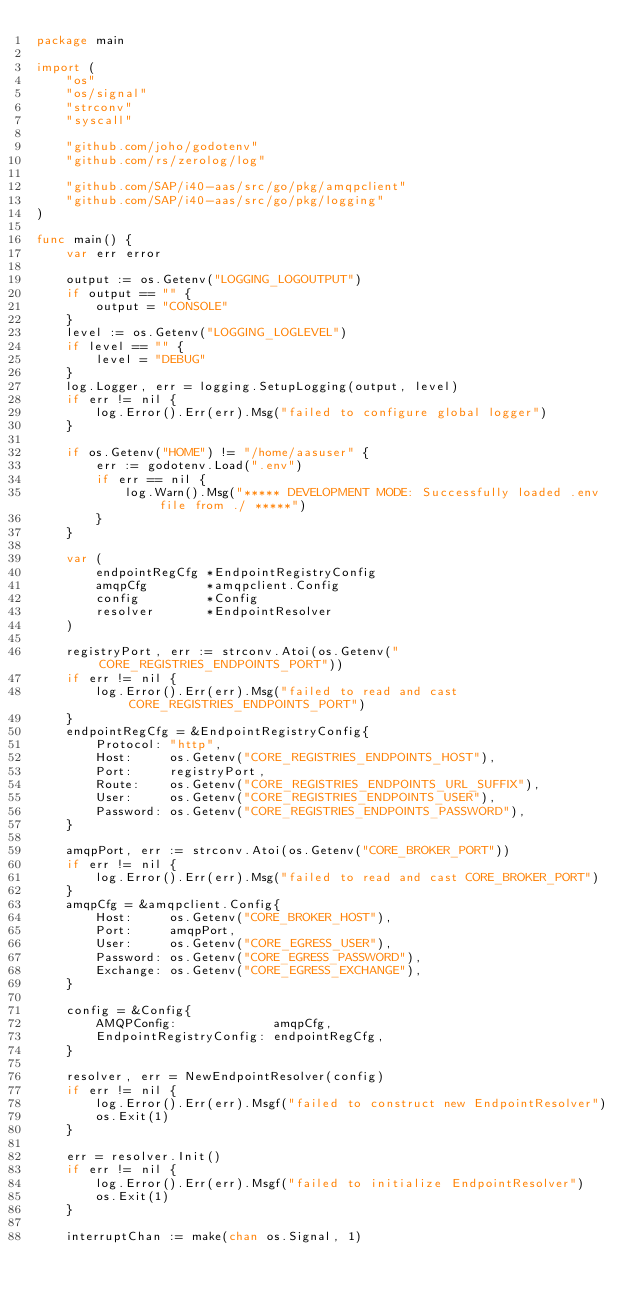Convert code to text. <code><loc_0><loc_0><loc_500><loc_500><_Go_>package main

import (
	"os"
	"os/signal"
	"strconv"
	"syscall"

	"github.com/joho/godotenv"
	"github.com/rs/zerolog/log"

	"github.com/SAP/i40-aas/src/go/pkg/amqpclient"
	"github.com/SAP/i40-aas/src/go/pkg/logging"
)

func main() {
	var err error

	output := os.Getenv("LOGGING_LOGOUTPUT")
	if output == "" {
		output = "CONSOLE"
	}
	level := os.Getenv("LOGGING_LOGLEVEL")
	if level == "" {
		level = "DEBUG"
	}
	log.Logger, err = logging.SetupLogging(output, level)
	if err != nil {
		log.Error().Err(err).Msg("failed to configure global logger")
	}

	if os.Getenv("HOME") != "/home/aasuser" {
		err := godotenv.Load(".env")
		if err == nil {
			log.Warn().Msg("***** DEVELOPMENT MODE: Successfully loaded .env file from ./ *****")
		}
	}

	var (
		endpointRegCfg *EndpointRegistryConfig
		amqpCfg        *amqpclient.Config
		config         *Config
		resolver       *EndpointResolver
	)

	registryPort, err := strconv.Atoi(os.Getenv("CORE_REGISTRIES_ENDPOINTS_PORT"))
	if err != nil {
		log.Error().Err(err).Msg("failed to read and cast CORE_REGISTRIES_ENDPOINTS_PORT")
	}
	endpointRegCfg = &EndpointRegistryConfig{
		Protocol: "http",
		Host:     os.Getenv("CORE_REGISTRIES_ENDPOINTS_HOST"),
		Port:     registryPort,
		Route:    os.Getenv("CORE_REGISTRIES_ENDPOINTS_URL_SUFFIX"),
		User:     os.Getenv("CORE_REGISTRIES_ENDPOINTS_USER"),
		Password: os.Getenv("CORE_REGISTRIES_ENDPOINTS_PASSWORD"),
	}

	amqpPort, err := strconv.Atoi(os.Getenv("CORE_BROKER_PORT"))
	if err != nil {
		log.Error().Err(err).Msg("failed to read and cast CORE_BROKER_PORT")
	}
	amqpCfg = &amqpclient.Config{
		Host:     os.Getenv("CORE_BROKER_HOST"),
		Port:     amqpPort,
		User:     os.Getenv("CORE_EGRESS_USER"),
		Password: os.Getenv("CORE_EGRESS_PASSWORD"),
		Exchange: os.Getenv("CORE_EGRESS_EXCHANGE"),
	}

	config = &Config{
		AMQPConfig:             amqpCfg,
		EndpointRegistryConfig: endpointRegCfg,
	}

	resolver, err = NewEndpointResolver(config)
	if err != nil {
		log.Error().Err(err).Msgf("failed to construct new EndpointResolver")
		os.Exit(1)
	}

	err = resolver.Init()
	if err != nil {
		log.Error().Err(err).Msgf("failed to initialize EndpointResolver")
		os.Exit(1)
	}

	interruptChan := make(chan os.Signal, 1)</code> 